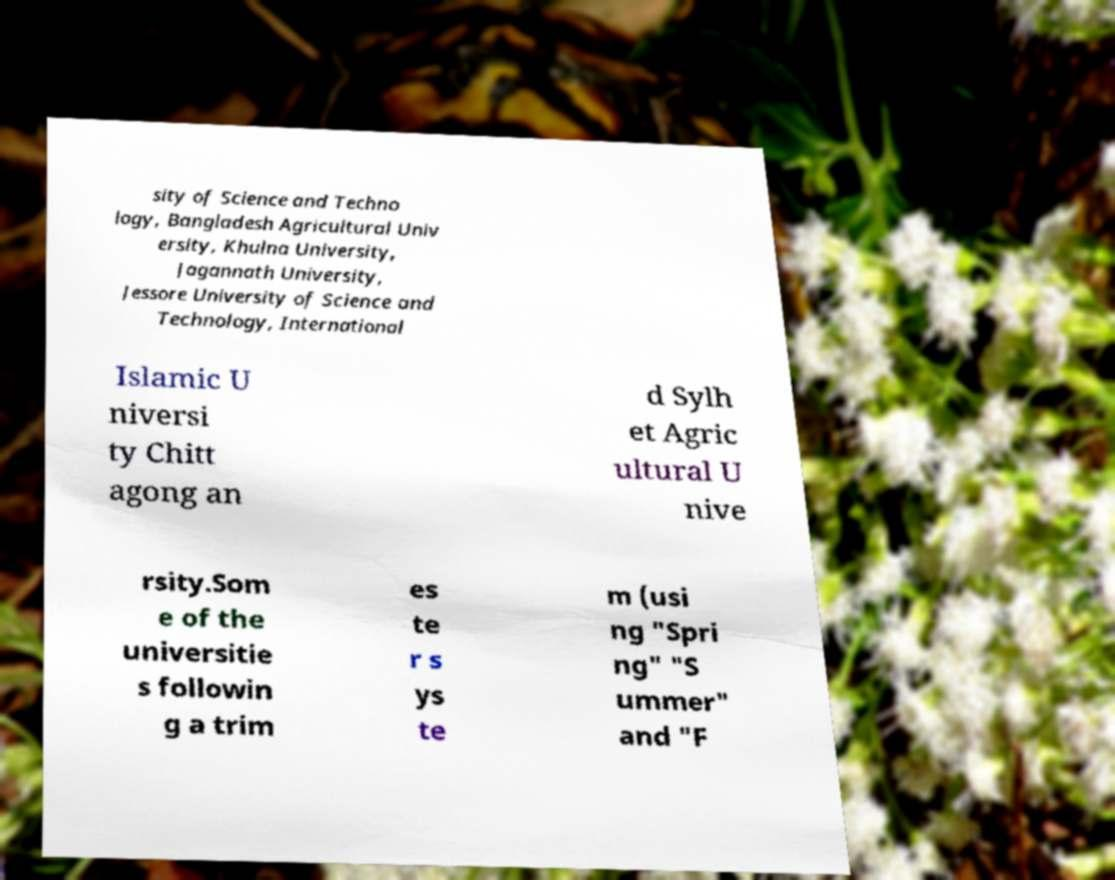Can you read and provide the text displayed in the image?This photo seems to have some interesting text. Can you extract and type it out for me? sity of Science and Techno logy, Bangladesh Agricultural Univ ersity, Khulna University, Jagannath University, Jessore University of Science and Technology, International Islamic U niversi ty Chitt agong an d Sylh et Agric ultural U nive rsity.Som e of the universitie s followin g a trim es te r s ys te m (usi ng "Spri ng" "S ummer" and "F 